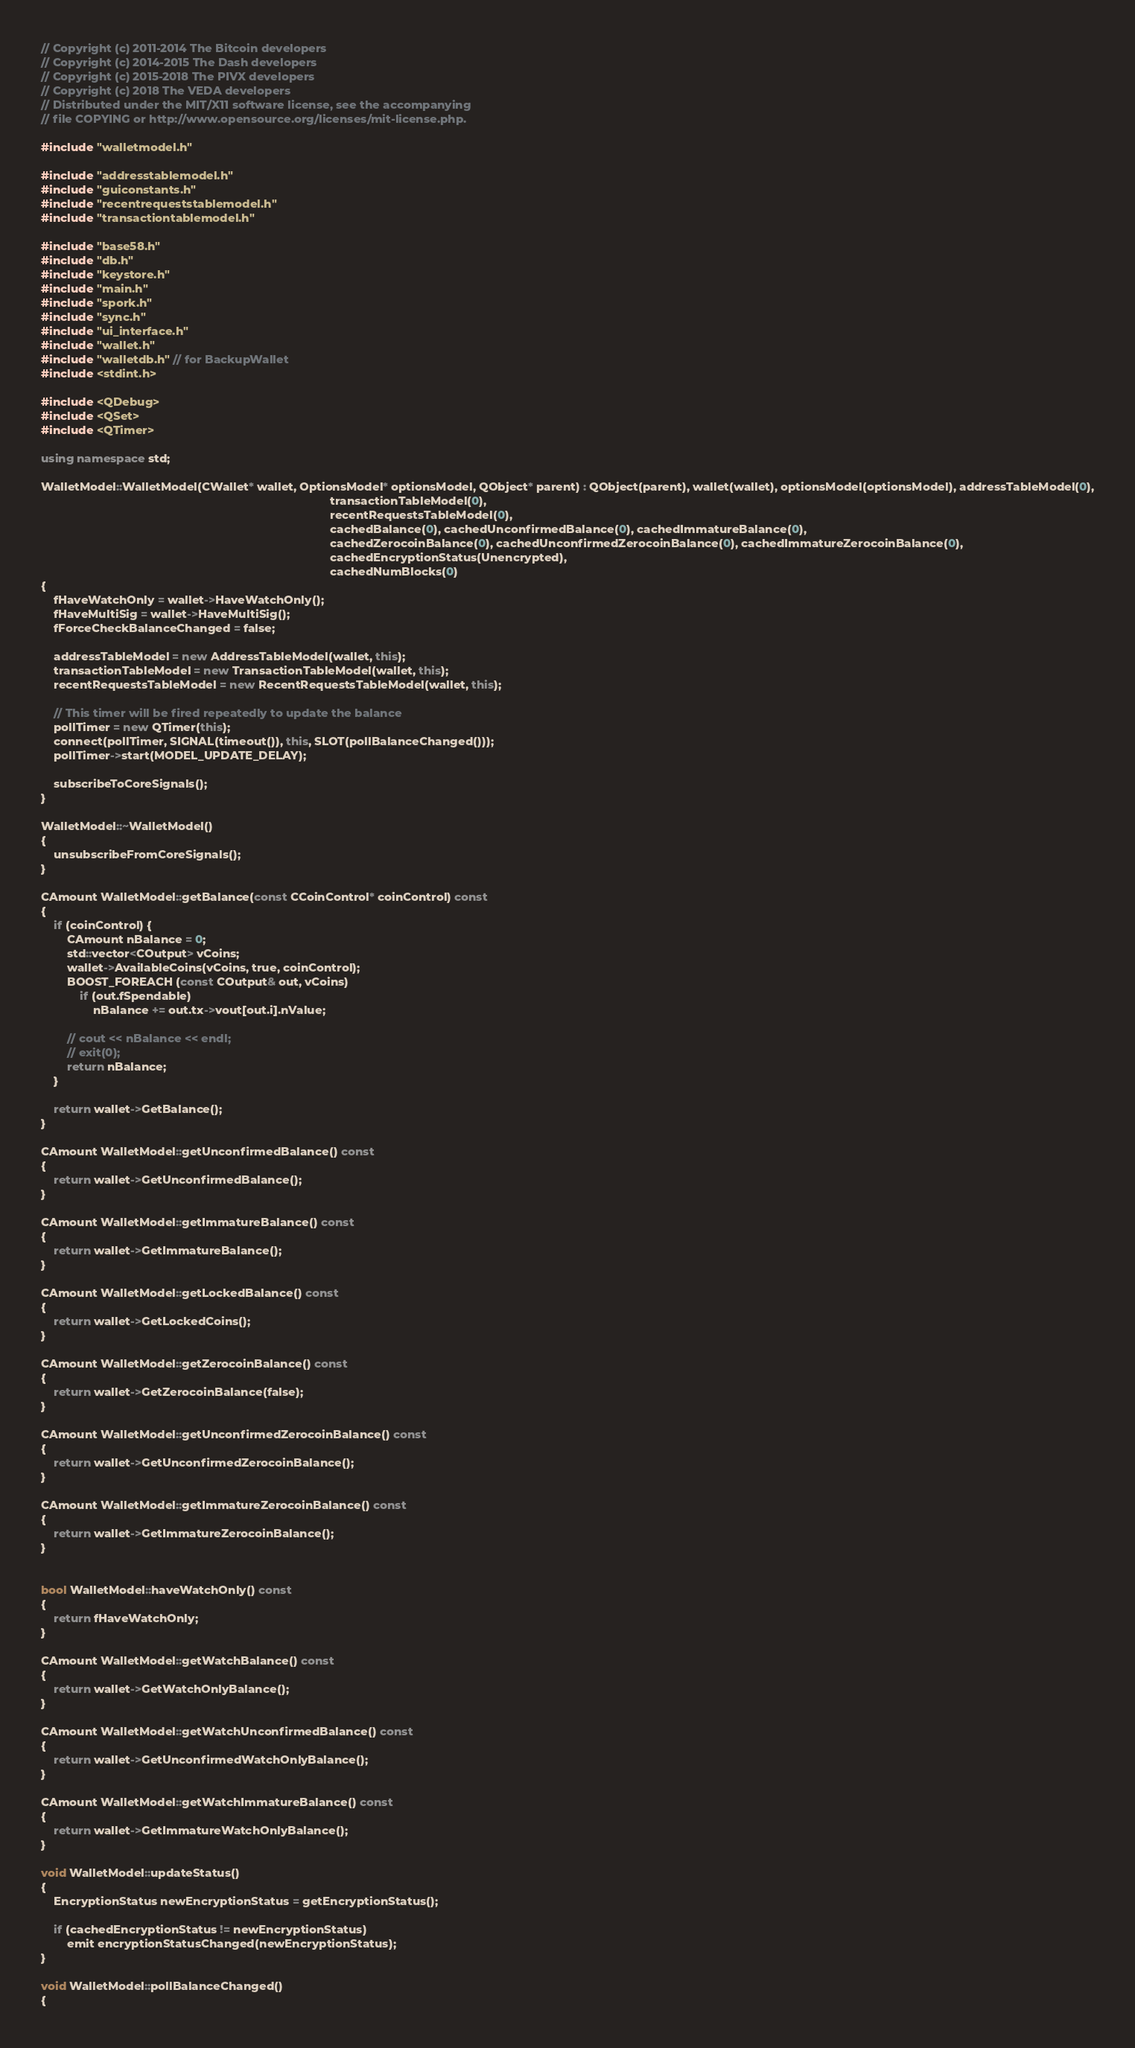Convert code to text. <code><loc_0><loc_0><loc_500><loc_500><_C++_>// Copyright (c) 2011-2014 The Bitcoin developers
// Copyright (c) 2014-2015 The Dash developers
// Copyright (c) 2015-2018 The PIVX developers
// Copyright (c) 2018 The VEDA developers
// Distributed under the MIT/X11 software license, see the accompanying
// file COPYING or http://www.opensource.org/licenses/mit-license.php.

#include "walletmodel.h"

#include "addresstablemodel.h"
#include "guiconstants.h"
#include "recentrequeststablemodel.h"
#include "transactiontablemodel.h"

#include "base58.h"
#include "db.h"
#include "keystore.h"
#include "main.h"
#include "spork.h"
#include "sync.h"
#include "ui_interface.h"
#include "wallet.h"
#include "walletdb.h" // for BackupWallet
#include <stdint.h>

#include <QDebug>
#include <QSet>
#include <QTimer>

using namespace std;

WalletModel::WalletModel(CWallet* wallet, OptionsModel* optionsModel, QObject* parent) : QObject(parent), wallet(wallet), optionsModel(optionsModel), addressTableModel(0),
                                                                                         transactionTableModel(0),
                                                                                         recentRequestsTableModel(0),
                                                                                         cachedBalance(0), cachedUnconfirmedBalance(0), cachedImmatureBalance(0),
                                                                                         cachedZerocoinBalance(0), cachedUnconfirmedZerocoinBalance(0), cachedImmatureZerocoinBalance(0),
                                                                                         cachedEncryptionStatus(Unencrypted),
                                                                                         cachedNumBlocks(0)
{
    fHaveWatchOnly = wallet->HaveWatchOnly();
    fHaveMultiSig = wallet->HaveMultiSig();
    fForceCheckBalanceChanged = false;

    addressTableModel = new AddressTableModel(wallet, this);
    transactionTableModel = new TransactionTableModel(wallet, this);
    recentRequestsTableModel = new RecentRequestsTableModel(wallet, this);

    // This timer will be fired repeatedly to update the balance
    pollTimer = new QTimer(this);
    connect(pollTimer, SIGNAL(timeout()), this, SLOT(pollBalanceChanged()));
    pollTimer->start(MODEL_UPDATE_DELAY);

    subscribeToCoreSignals();
}

WalletModel::~WalletModel()
{
    unsubscribeFromCoreSignals();
}

CAmount WalletModel::getBalance(const CCoinControl* coinControl) const
{
    if (coinControl) {
        CAmount nBalance = 0;
        std::vector<COutput> vCoins;
        wallet->AvailableCoins(vCoins, true, coinControl);
        BOOST_FOREACH (const COutput& out, vCoins)
            if (out.fSpendable)
                nBalance += out.tx->vout[out.i].nValue;

        // cout << nBalance << endl;
        // exit(0);
        return nBalance;
    }

    return wallet->GetBalance();
}

CAmount WalletModel::getUnconfirmedBalance() const
{
    return wallet->GetUnconfirmedBalance();
}

CAmount WalletModel::getImmatureBalance() const
{
    return wallet->GetImmatureBalance();
}

CAmount WalletModel::getLockedBalance() const
{
    return wallet->GetLockedCoins();
}

CAmount WalletModel::getZerocoinBalance() const
{
    return wallet->GetZerocoinBalance(false);
}

CAmount WalletModel::getUnconfirmedZerocoinBalance() const
{
    return wallet->GetUnconfirmedZerocoinBalance();
}

CAmount WalletModel::getImmatureZerocoinBalance() const
{
    return wallet->GetImmatureZerocoinBalance();
}


bool WalletModel::haveWatchOnly() const
{
    return fHaveWatchOnly;
}

CAmount WalletModel::getWatchBalance() const
{
    return wallet->GetWatchOnlyBalance();
}

CAmount WalletModel::getWatchUnconfirmedBalance() const
{
    return wallet->GetUnconfirmedWatchOnlyBalance();
}

CAmount WalletModel::getWatchImmatureBalance() const
{
    return wallet->GetImmatureWatchOnlyBalance();
}

void WalletModel::updateStatus()
{
    EncryptionStatus newEncryptionStatus = getEncryptionStatus();

    if (cachedEncryptionStatus != newEncryptionStatus)
        emit encryptionStatusChanged(newEncryptionStatus);
}

void WalletModel::pollBalanceChanged()
{</code> 